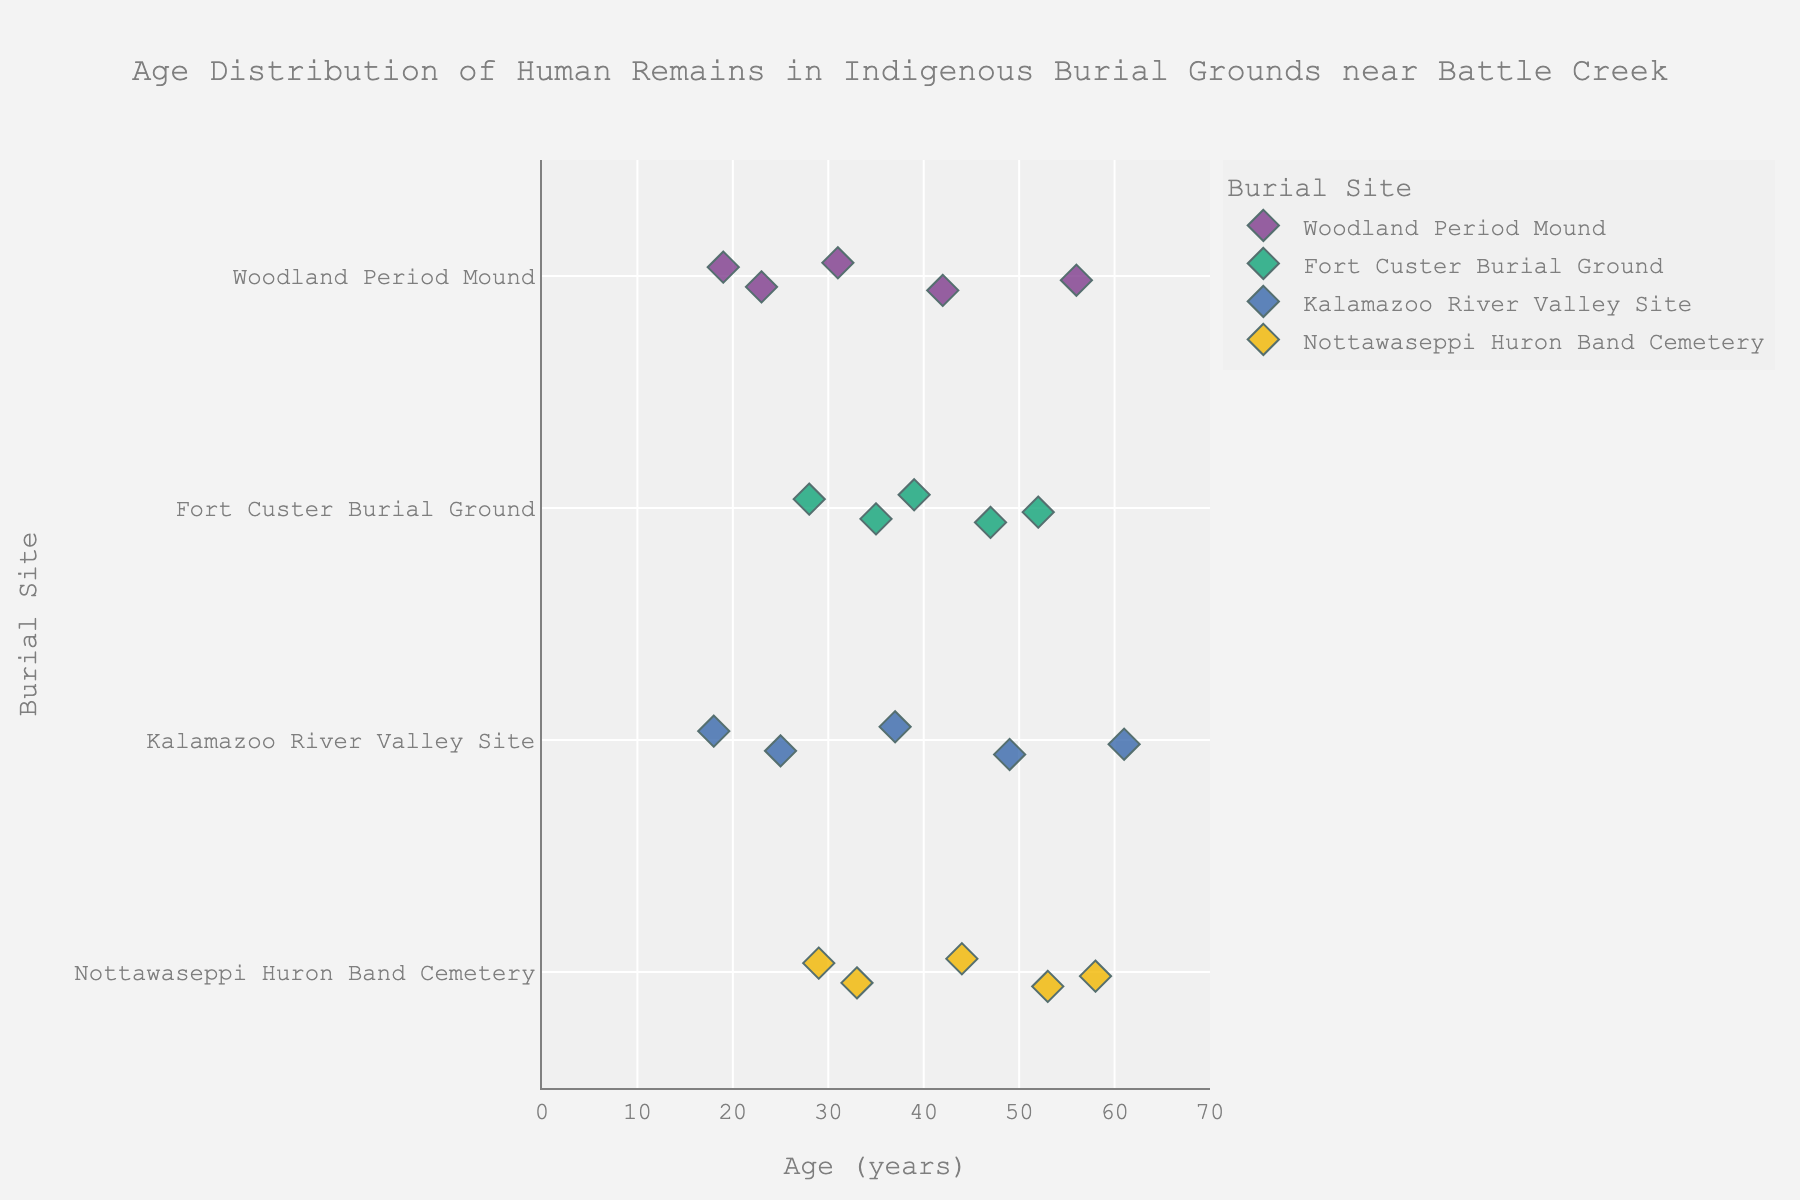What is the youngest age found at the Woodland Period Mound site? To find the youngest age, look for the data points at the Woodland Period Mound site and identify the smallest age value.
Answer: 19 What is the age range of human remains discovered at the Kalamazoo River Valley Site? The age range is the difference between the oldest and youngest ages. For the Kalamazoo River Valley Site, identify the maximum age (61) and minimum age (18), then subtract the minimum from the maximum.
Answer: 43 Which site has the most diverse age distribution based on the visual spread of data points? Look at the spread of data points for each site on the plot. The Kalamazoo River Valley Site shows the most diverse distribution with ages ranging from 18 to 61.
Answer: Kalamazoo River Valley Site How many age groups above 50 years old are at the various sites? Count the number of data points in each category that are above 50 years: Woodland Period Mound (1), Fort Custer Burial Ground (2), Kalamazoo River Valley Site (2), Nottawaseppi Huron Band Cemetery (2). Then sum these counts.
Answer: 7 What is the most common age range for remains found at the Nottawaseppi Huron Band Cemetery? Observe the plot for the Nottawaseppi Huron Band Cemetery and note the density of points to identify the common age range. Ages cluster around the 40-60 range.
Answer: 40-60 Which site shows the least variation in ages of human remains? The site with the closest clustering of data points visually indicates the least variation. The Woodland Period Mound site has ages clustered between 19 and 56, showing moderate variation. Others have wider ranges.
Answer: Woodland Period Mound What is the oldest age found at any of the sites? Identify the maximum age value across all sites. The highest data point is 61 at the Kalamazoo River Valley Site.
Answer: 61 